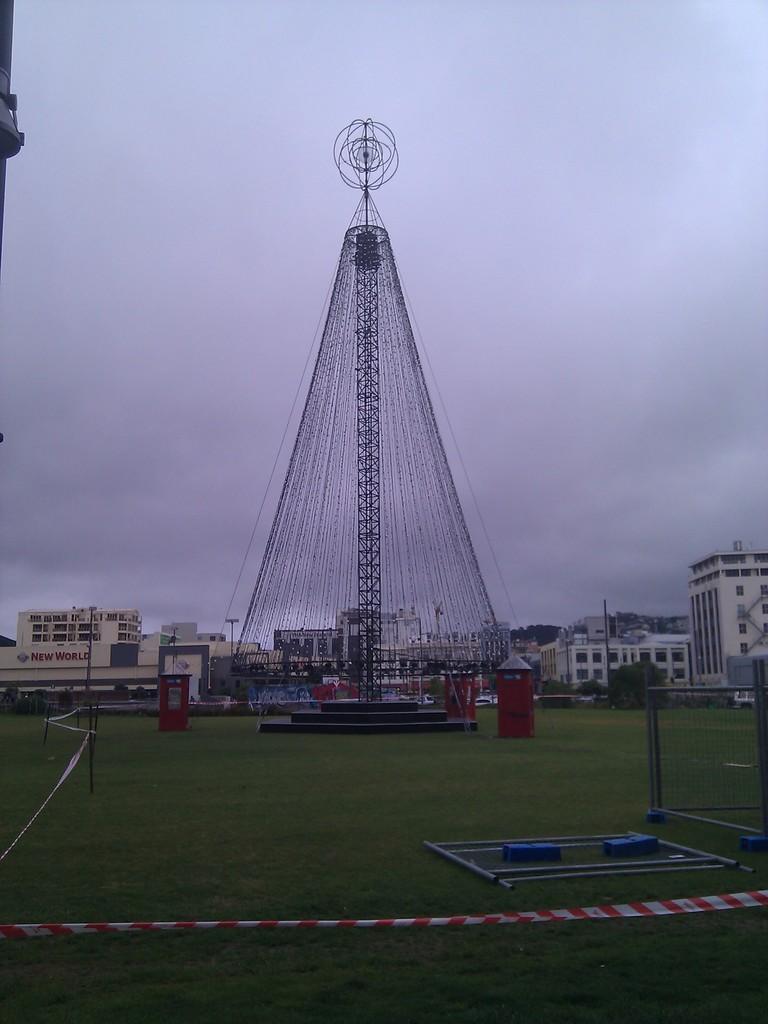How would you summarize this image in a sentence or two? At the bottom of the image I can see the grass. This is looking like a playing ground. In the background, I can see a transmission pole and many buildings. At the top of the image I can see the sky. 